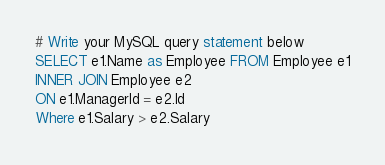Convert code to text. <code><loc_0><loc_0><loc_500><loc_500><_SQL_># Write your MySQL query statement below
SELECT e1.Name as Employee FROM Employee e1
INNER JOIN Employee e2
ON e1.ManagerId = e2.Id
Where e1.Salary > e2.Salary</code> 